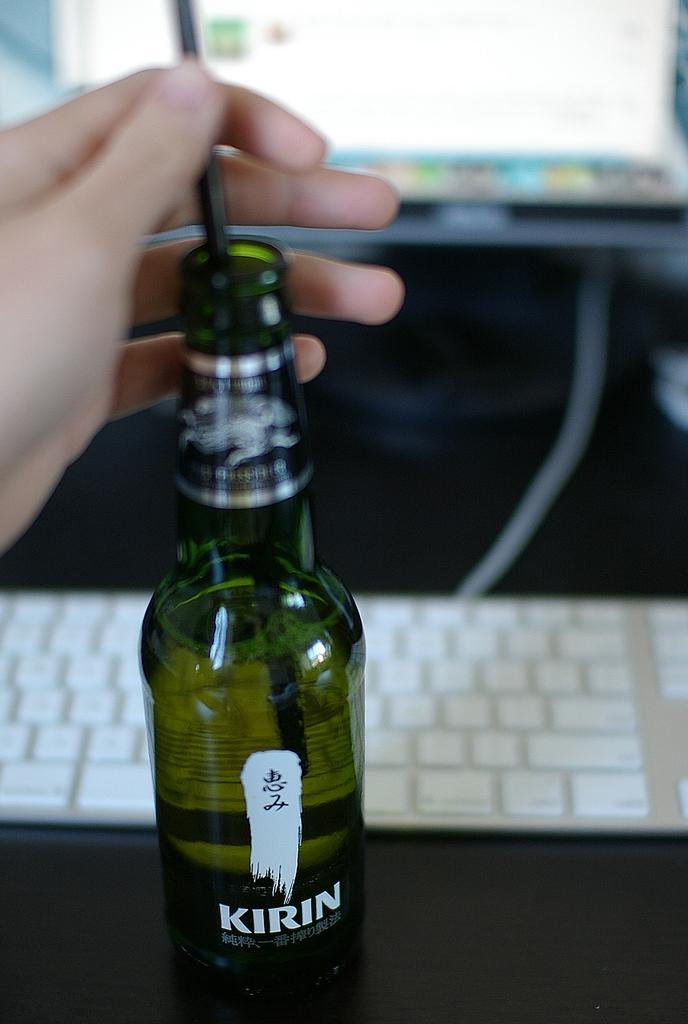<image>
Provide a brief description of the given image. A bottle of Kirin beer sits infront of a keyboard. 